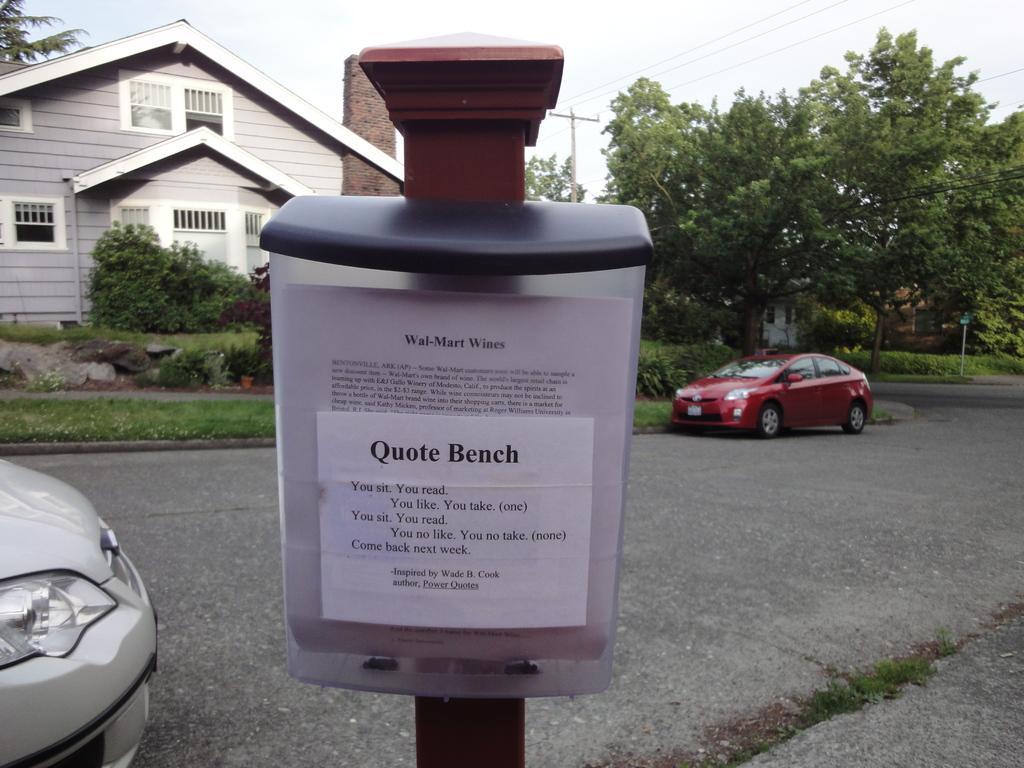Can you describe this image briefly? In the image in the center, we can see one pole and we can see one box attached to the pole. On the box, it is written as "Quote Bench". And we can see two cars on the road. In the background, we can see the sky, clouds, trees, plants, grass, one sign board, on building, windows etc. 